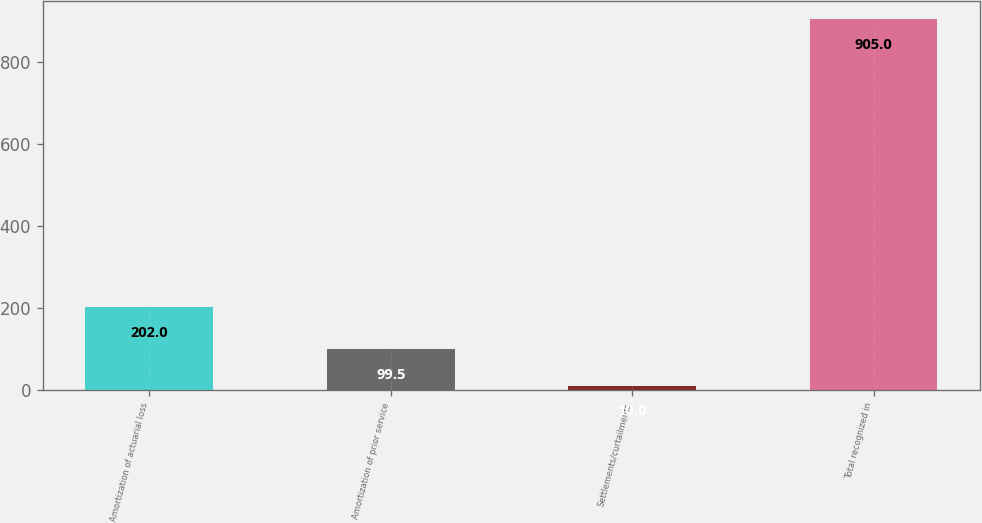Convert chart to OTSL. <chart><loc_0><loc_0><loc_500><loc_500><bar_chart><fcel>Amortization of actuarial loss<fcel>Amortization of prior service<fcel>Settlements/curtailments<fcel>Total recognized in<nl><fcel>202<fcel>99.5<fcel>10<fcel>905<nl></chart> 